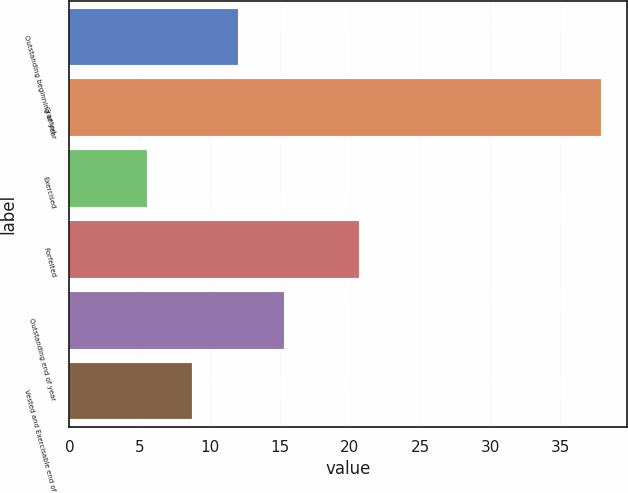Convert chart to OTSL. <chart><loc_0><loc_0><loc_500><loc_500><bar_chart><fcel>Outstanding beginning of year<fcel>Granted<fcel>Exercised<fcel>Forfeited<fcel>Outstanding end of year<fcel>Vested and Exercisable end of<nl><fcel>12<fcel>37.88<fcel>5.53<fcel>20.66<fcel>15.3<fcel>8.77<nl></chart> 